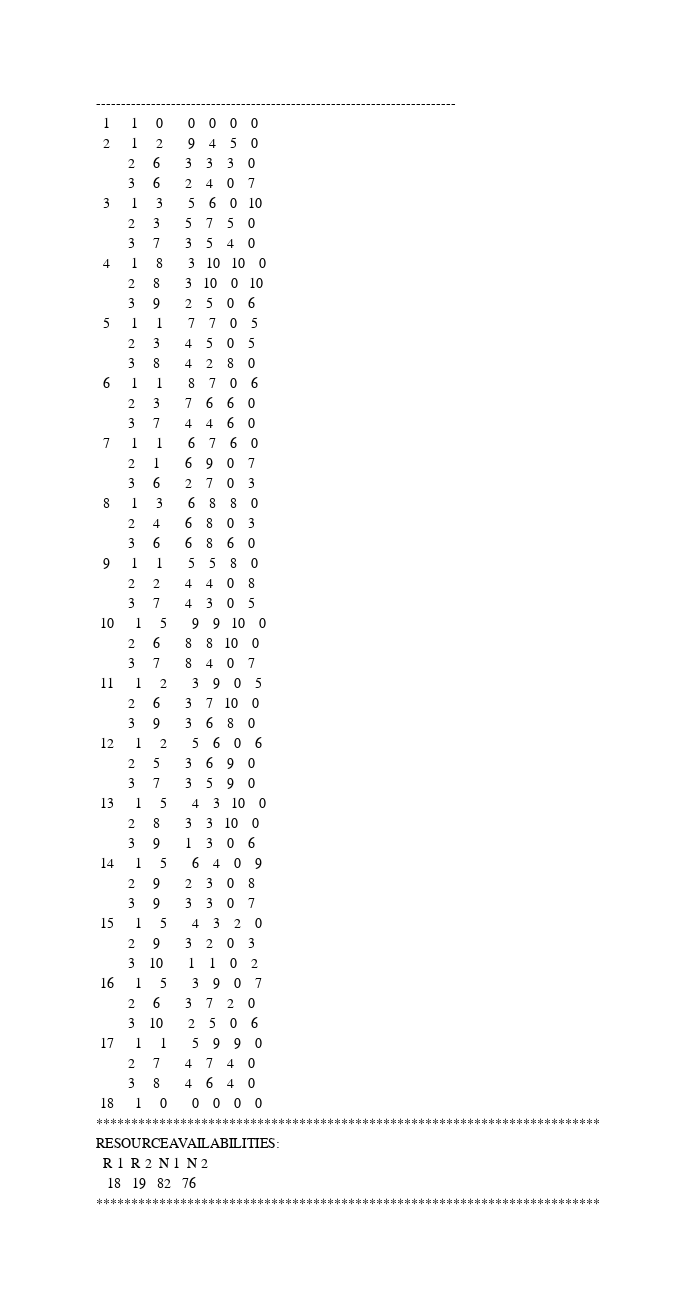Convert code to text. <code><loc_0><loc_0><loc_500><loc_500><_ObjectiveC_>------------------------------------------------------------------------
  1      1     0       0    0    0    0
  2      1     2       9    4    5    0
         2     6       3    3    3    0
         3     6       2    4    0    7
  3      1     3       5    6    0   10
         2     3       5    7    5    0
         3     7       3    5    4    0
  4      1     8       3   10   10    0
         2     8       3   10    0   10
         3     9       2    5    0    6
  5      1     1       7    7    0    5
         2     3       4    5    0    5
         3     8       4    2    8    0
  6      1     1       8    7    0    6
         2     3       7    6    6    0
         3     7       4    4    6    0
  7      1     1       6    7    6    0
         2     1       6    9    0    7
         3     6       2    7    0    3
  8      1     3       6    8    8    0
         2     4       6    8    0    3
         3     6       6    8    6    0
  9      1     1       5    5    8    0
         2     2       4    4    0    8
         3     7       4    3    0    5
 10      1     5       9    9   10    0
         2     6       8    8   10    0
         3     7       8    4    0    7
 11      1     2       3    9    0    5
         2     6       3    7   10    0
         3     9       3    6    8    0
 12      1     2       5    6    0    6
         2     5       3    6    9    0
         3     7       3    5    9    0
 13      1     5       4    3   10    0
         2     8       3    3   10    0
         3     9       1    3    0    6
 14      1     5       6    4    0    9
         2     9       2    3    0    8
         3     9       3    3    0    7
 15      1     5       4    3    2    0
         2     9       3    2    0    3
         3    10       1    1    0    2
 16      1     5       3    9    0    7
         2     6       3    7    2    0
         3    10       2    5    0    6
 17      1     1       5    9    9    0
         2     7       4    7    4    0
         3     8       4    6    4    0
 18      1     0       0    0    0    0
************************************************************************
RESOURCEAVAILABILITIES:
  R 1  R 2  N 1  N 2
   18   19   82   76
************************************************************************
</code> 